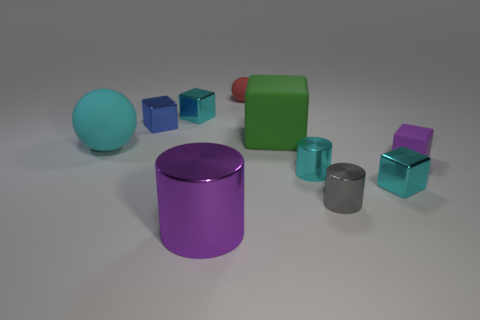Do the large cylinder and the small matte block have the same color?
Offer a terse response. Yes. There is a small cylinder that is the same color as the large rubber ball; what is its material?
Keep it short and to the point. Metal. Do the small block in front of the tiny purple cube and the rubber sphere on the left side of the purple shiny thing have the same color?
Provide a short and direct response. Yes. What number of tiny metal objects are the same color as the large sphere?
Make the answer very short. 3. Does the purple cylinder have the same material as the tiny gray object that is to the right of the red rubber sphere?
Make the answer very short. Yes. Are there any other things that are the same shape as the red matte thing?
Your answer should be very brief. Yes. The shiny thing that is to the left of the red matte object and in front of the small blue shiny block is what color?
Provide a short and direct response. Purple. The small cyan thing that is behind the blue cube has what shape?
Give a very brief answer. Cube. What is the size of the purple object that is in front of the small object that is in front of the small metal block in front of the tiny purple thing?
Offer a terse response. Large. How many tiny blue cubes are behind the small cyan metallic cube behind the large matte block?
Offer a terse response. 0. 